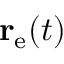Convert formula to latex. <formula><loc_0><loc_0><loc_500><loc_500>r _ { e } ( t )</formula> 